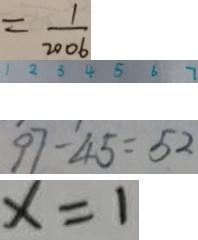Convert formula to latex. <formula><loc_0><loc_0><loc_500><loc_500>= \frac { 1 } { 2 0 0 6 } 
 1 2 3 4 5 6 7 
 9 7 - 4 5 = 5 2 
 x = 1</formula> 